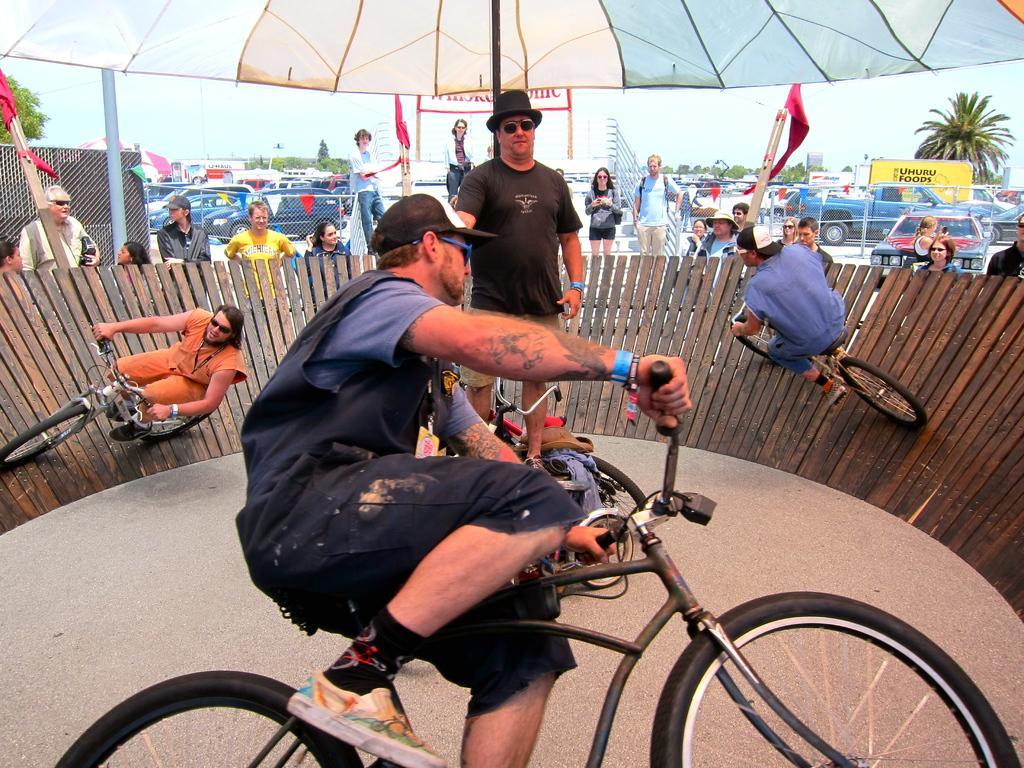Can you describe this image briefly? In this picture we can see person standing in middle wore goggle, cap and beside to him three persons riding bicycle on wooden floor and in background we can see some more persons, fence, car, tree. 